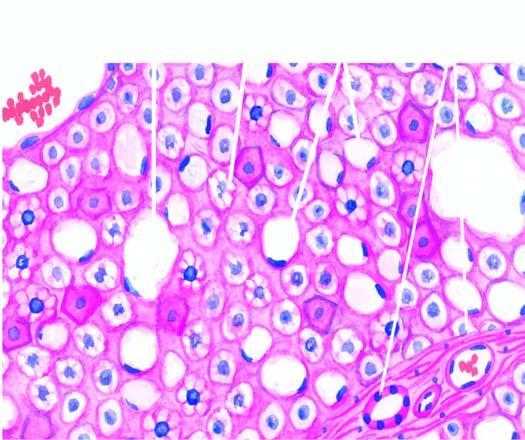what show multiple small vacuoles in the cytoplasm microvesicles?
Answer the question using a single word or phrase. Others hepatocytes 